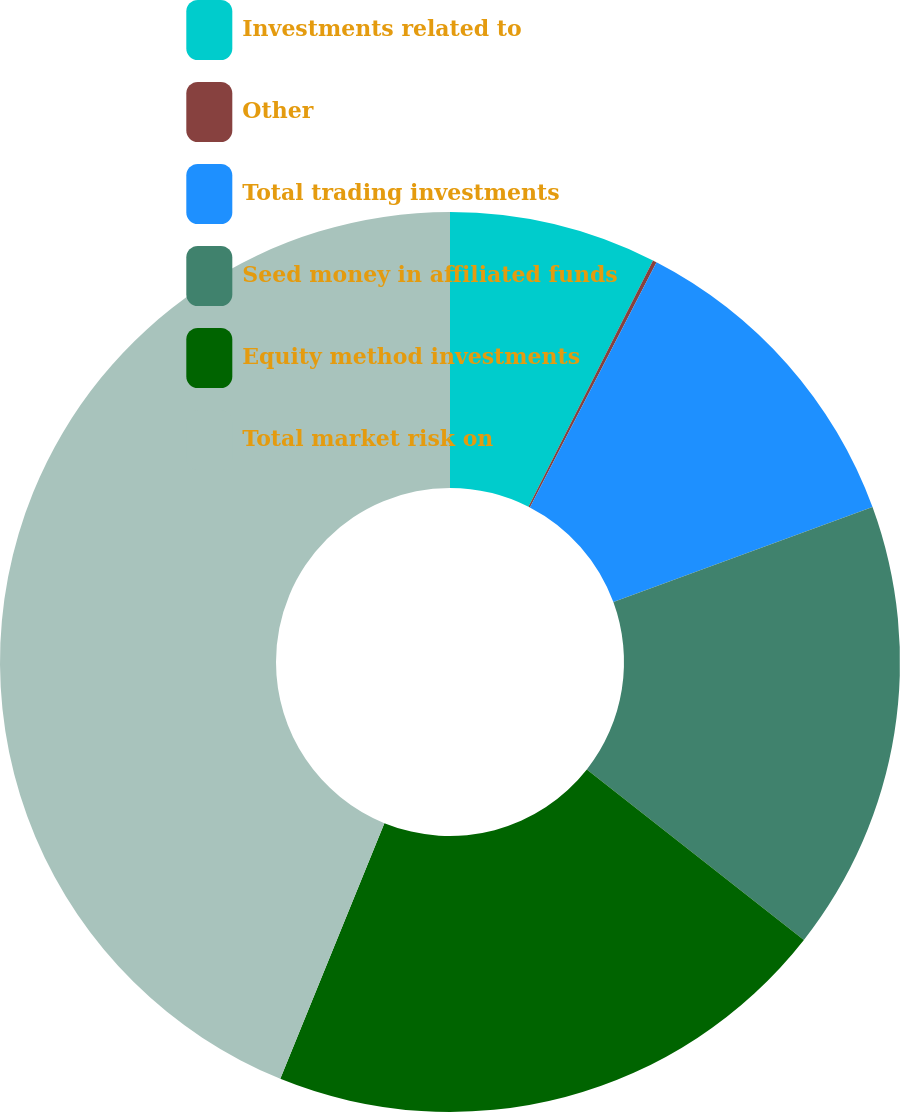Convert chart to OTSL. <chart><loc_0><loc_0><loc_500><loc_500><pie_chart><fcel>Investments related to<fcel>Other<fcel>Total trading investments<fcel>Seed money in affiliated funds<fcel>Equity method investments<fcel>Total market risk on<nl><fcel>7.45%<fcel>0.14%<fcel>11.82%<fcel>16.19%<fcel>20.56%<fcel>43.85%<nl></chart> 